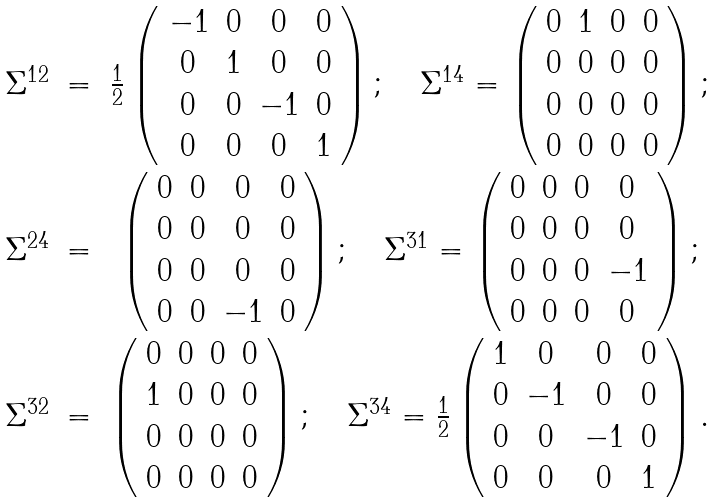<formula> <loc_0><loc_0><loc_500><loc_500>\begin{array} { c c c } \Sigma ^ { 1 2 } & = & \frac { 1 } { 2 } \left ( \begin{array} { c c c c } - 1 & 0 & 0 & 0 \\ 0 & 1 & 0 & 0 \\ 0 & 0 & - 1 & 0 \\ 0 & 0 & 0 & 1 \end{array} \right ) ; \quad \Sigma ^ { 1 4 } = \left ( \begin{array} { c c c c } 0 & 1 & 0 & 0 \\ 0 & 0 & 0 & 0 \\ 0 & 0 & 0 & 0 \\ 0 & 0 & 0 & 0 \end{array} \right ) ; \\ \Sigma ^ { 2 4 } & = & \left ( \begin{array} { c c c c } 0 & 0 & 0 & 0 \\ 0 & 0 & 0 & 0 \\ 0 & 0 & 0 & 0 \\ 0 & 0 & - 1 & 0 \end{array} \right ) ; \quad \Sigma ^ { 3 1 } = \left ( \begin{array} { c c c c } 0 & 0 & 0 & 0 \\ 0 & 0 & 0 & 0 \\ 0 & 0 & 0 & - 1 \\ 0 & 0 & 0 & 0 \end{array} \right ) ; \\ \Sigma ^ { 3 2 } & = & \left ( \begin{array} { c c c c } 0 & 0 & 0 & 0 \\ 1 & 0 & 0 & 0 \\ 0 & 0 & 0 & 0 \\ 0 & 0 & 0 & 0 \end{array} \right ) ; \quad \Sigma ^ { 3 4 } = \frac { 1 } { 2 } \left ( \begin{array} { c c c c } 1 & 0 & 0 & 0 \\ 0 & - 1 & 0 & 0 \\ 0 & 0 & - 1 & 0 \\ 0 & 0 & 0 & 1 \end{array} \right ) . \end{array}</formula> 